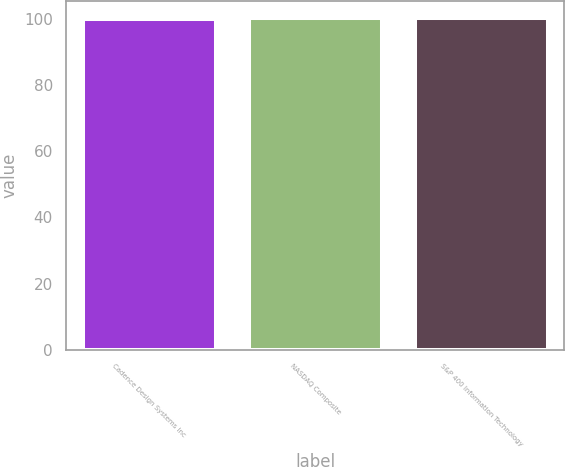<chart> <loc_0><loc_0><loc_500><loc_500><bar_chart><fcel>Cadence Design Systems Inc<fcel>NASDAQ Composite<fcel>S&P 400 Information Technology<nl><fcel>100<fcel>100.1<fcel>100.2<nl></chart> 